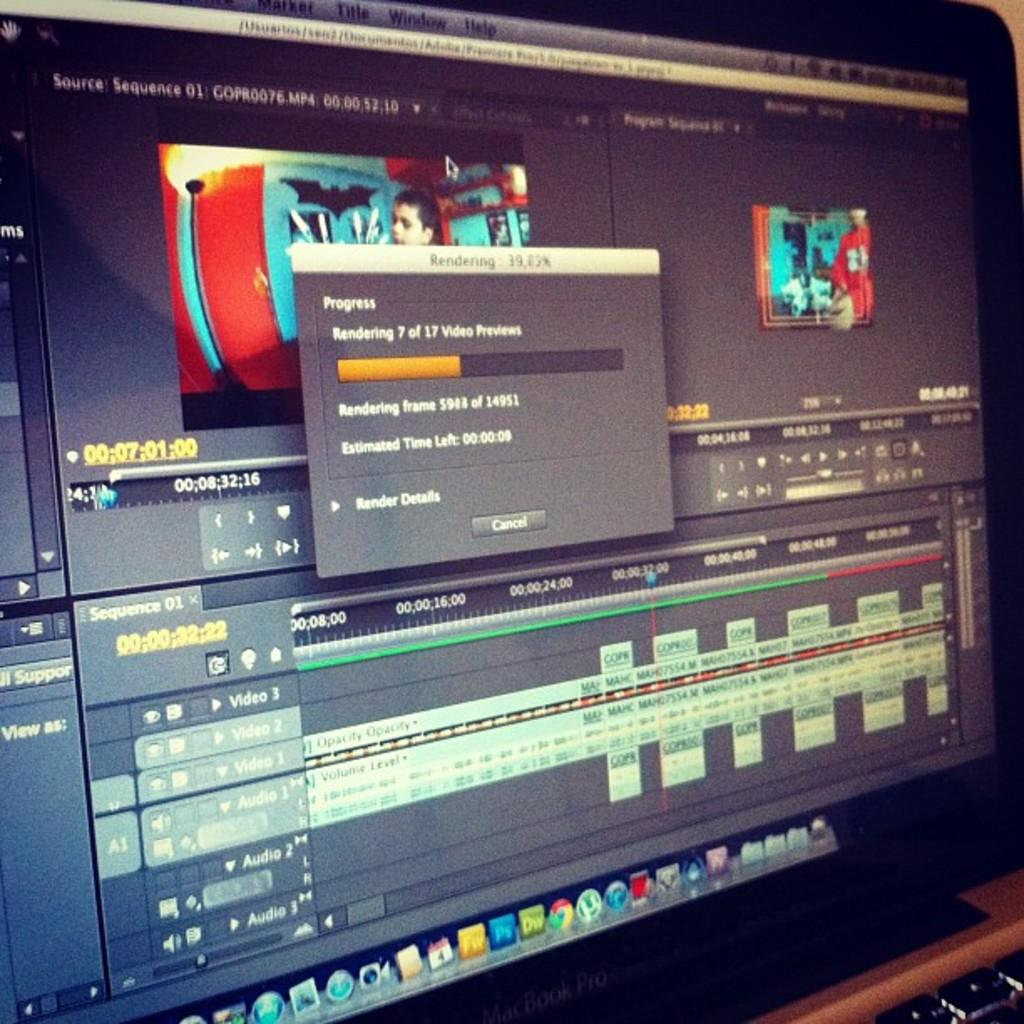<image>
Render a clear and concise summary of the photo. Macbook Pro laptop monitor showing a progress bar. 